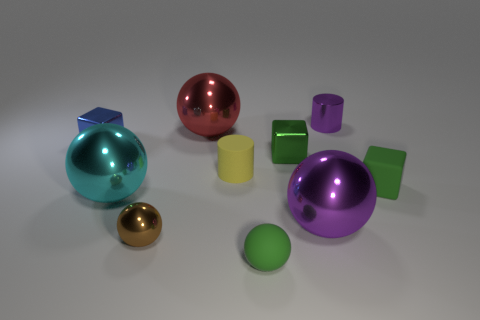There is a green thing that is the same shape as the brown object; what is it made of?
Offer a terse response. Rubber. How many blocks are the same color as the small metal cylinder?
Offer a terse response. 0. The red sphere that is the same material as the blue block is what size?
Keep it short and to the point. Large. What number of gray objects are either metallic balls or big shiny objects?
Offer a very short reply. 0. What number of tiny matte objects are on the right side of the purple object that is behind the yellow thing?
Offer a terse response. 1. Are there more small yellow rubber objects behind the small blue metallic object than things that are behind the brown shiny object?
Provide a succinct answer. No. What is the material of the big purple ball?
Ensure brevity in your answer.  Metal. Are there any blue blocks of the same size as the purple sphere?
Provide a short and direct response. No. There is a purple thing that is the same size as the green shiny thing; what is its material?
Provide a short and direct response. Metal. How many tiny balls are there?
Ensure brevity in your answer.  2. 